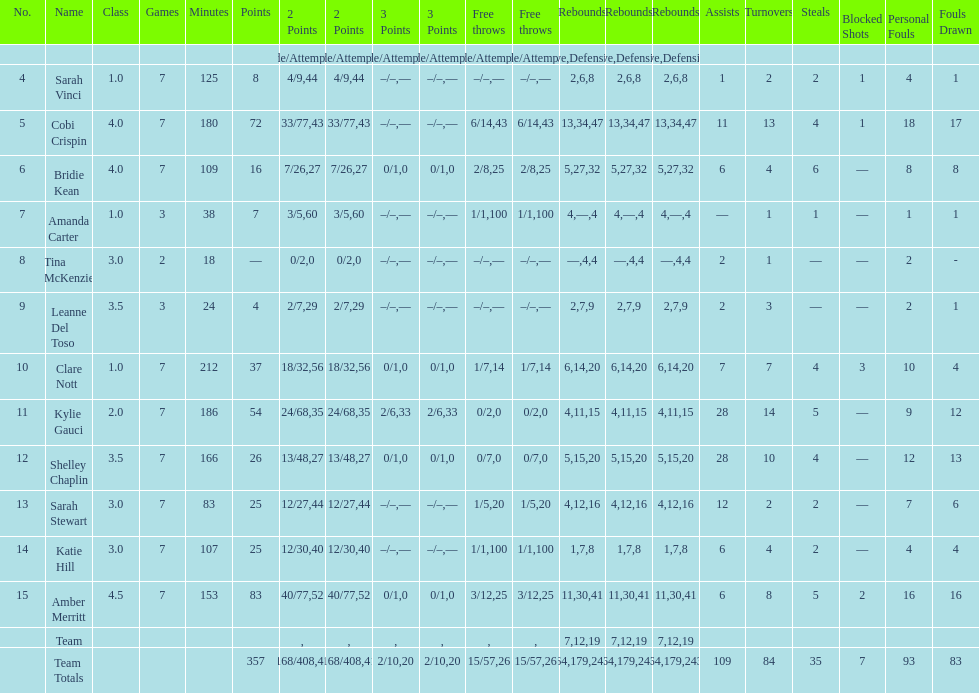Would you mind parsing the complete table? {'header': ['No.', 'Name', 'Class', 'Games', 'Minutes', 'Points', '2 Points', '2 Points', '3 Points', '3 Points', 'Free throws', 'Free throws', 'Rebounds', 'Rebounds', 'Rebounds', 'Assists', 'Turnovers', 'Steals', 'Blocked Shots', 'Personal Fouls', 'Fouls Drawn'], 'rows': [['', '', '', '', '', '', 'Made/Attempts', '%', 'Made/Attempts', '%', 'Made/Attempts', '%', 'Offensive', 'Defensive', 'Total', '', '', '', '', '', ''], ['4', 'Sarah Vinci', '1.0', '7', '125', '8', '4/9', '44', '–/–', '—', '–/–', '—', '2', '6', '8', '1', '2', '2', '1', '4', '1'], ['5', 'Cobi Crispin', '4.0', '7', '180', '72', '33/77', '43', '–/–', '—', '6/14', '43', '13', '34', '47', '11', '13', '4', '1', '18', '17'], ['6', 'Bridie Kean', '4.0', '7', '109', '16', '7/26', '27', '0/1', '0', '2/8', '25', '5', '27', '32', '6', '4', '6', '—', '8', '8'], ['7', 'Amanda Carter', '1.0', '3', '38', '7', '3/5', '60', '–/–', '—', '1/1', '100', '4', '—', '4', '—', '1', '1', '—', '1', '1'], ['8', 'Tina McKenzie', '3.0', '2', '18', '—', '0/2', '0', '–/–', '—', '–/–', '—', '—', '4', '4', '2', '1', '—', '—', '2', '-'], ['9', 'Leanne Del Toso', '3.5', '3', '24', '4', '2/7', '29', '–/–', '—', '–/–', '—', '2', '7', '9', '2', '3', '—', '—', '2', '1'], ['10', 'Clare Nott', '1.0', '7', '212', '37', '18/32', '56', '0/1', '0', '1/7', '14', '6', '14', '20', '7', '7', '4', '3', '10', '4'], ['11', 'Kylie Gauci', '2.0', '7', '186', '54', '24/68', '35', '2/6', '33', '0/2', '0', '4', '11', '15', '28', '14', '5', '—', '9', '12'], ['12', 'Shelley Chaplin', '3.5', '7', '166', '26', '13/48', '27', '0/1', '0', '0/7', '0', '5', '15', '20', '28', '10', '4', '—', '12', '13'], ['13', 'Sarah Stewart', '3.0', '7', '83', '25', '12/27', '44', '–/–', '—', '1/5', '20', '4', '12', '16', '12', '2', '2', '—', '7', '6'], ['14', 'Katie Hill', '3.0', '7', '107', '25', '12/30', '40', '–/–', '—', '1/1', '100', '1', '7', '8', '6', '4', '2', '—', '4', '4'], ['15', 'Amber Merritt', '4.5', '7', '153', '83', '40/77', '52', '0/1', '0', '3/12', '25', '11', '30', '41', '6', '8', '5', '2', '16', '16'], ['', 'Team', '', '', '', '', '', '', '', '', '', '', '7', '12', '19', '', '', '', '', '', ''], ['', 'Team Totals', '', '', '', '357', '168/408', '41', '2/10', '20', '15/57', '26', '64', '179', '243', '109', '84', '35', '7', '93', '83']]} What is the difference between the maximum scoring player's points and the minimum scoring player's points? 83. 